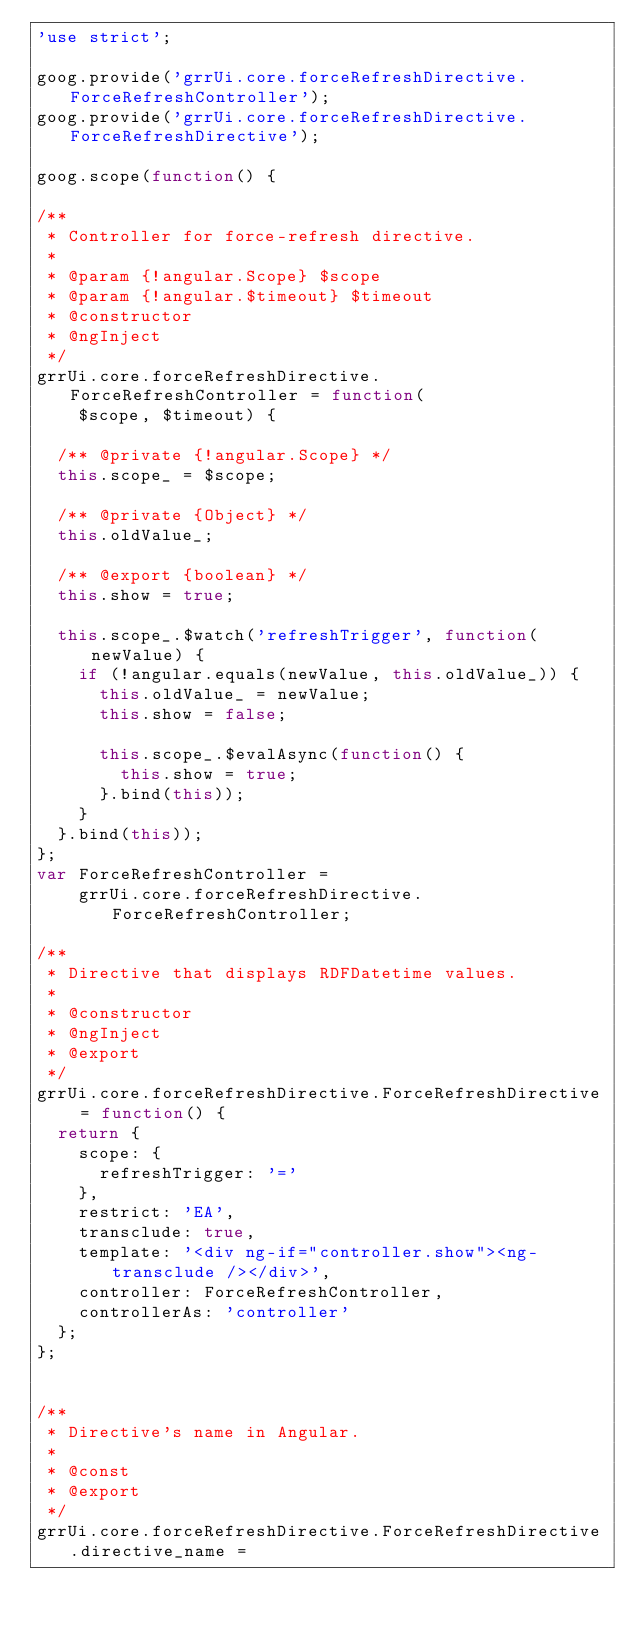<code> <loc_0><loc_0><loc_500><loc_500><_JavaScript_>'use strict';

goog.provide('grrUi.core.forceRefreshDirective.ForceRefreshController');
goog.provide('grrUi.core.forceRefreshDirective.ForceRefreshDirective');

goog.scope(function() {

/**
 * Controller for force-refresh directive.
 *
 * @param {!angular.Scope} $scope
 * @param {!angular.$timeout} $timeout
 * @constructor
 * @ngInject
 */
grrUi.core.forceRefreshDirective.ForceRefreshController = function(
    $scope, $timeout) {

  /** @private {!angular.Scope} */
  this.scope_ = $scope;

  /** @private {Object} */
  this.oldValue_;

  /** @export {boolean} */
  this.show = true;

  this.scope_.$watch('refreshTrigger', function(newValue) {
    if (!angular.equals(newValue, this.oldValue_)) {
      this.oldValue_ = newValue;
      this.show = false;

      this.scope_.$evalAsync(function() {
        this.show = true;
      }.bind(this));
    }
  }.bind(this));
};
var ForceRefreshController =
    grrUi.core.forceRefreshDirective.ForceRefreshController;

/**
 * Directive that displays RDFDatetime values.
 *
 * @constructor
 * @ngInject
 * @export
 */
grrUi.core.forceRefreshDirective.ForceRefreshDirective = function() {
  return {
    scope: {
      refreshTrigger: '='
    },
    restrict: 'EA',
    transclude: true,
    template: '<div ng-if="controller.show"><ng-transclude /></div>',
    controller: ForceRefreshController,
    controllerAs: 'controller'
  };
};


/**
 * Directive's name in Angular.
 *
 * @const
 * @export
 */
grrUi.core.forceRefreshDirective.ForceRefreshDirective.directive_name =</code> 